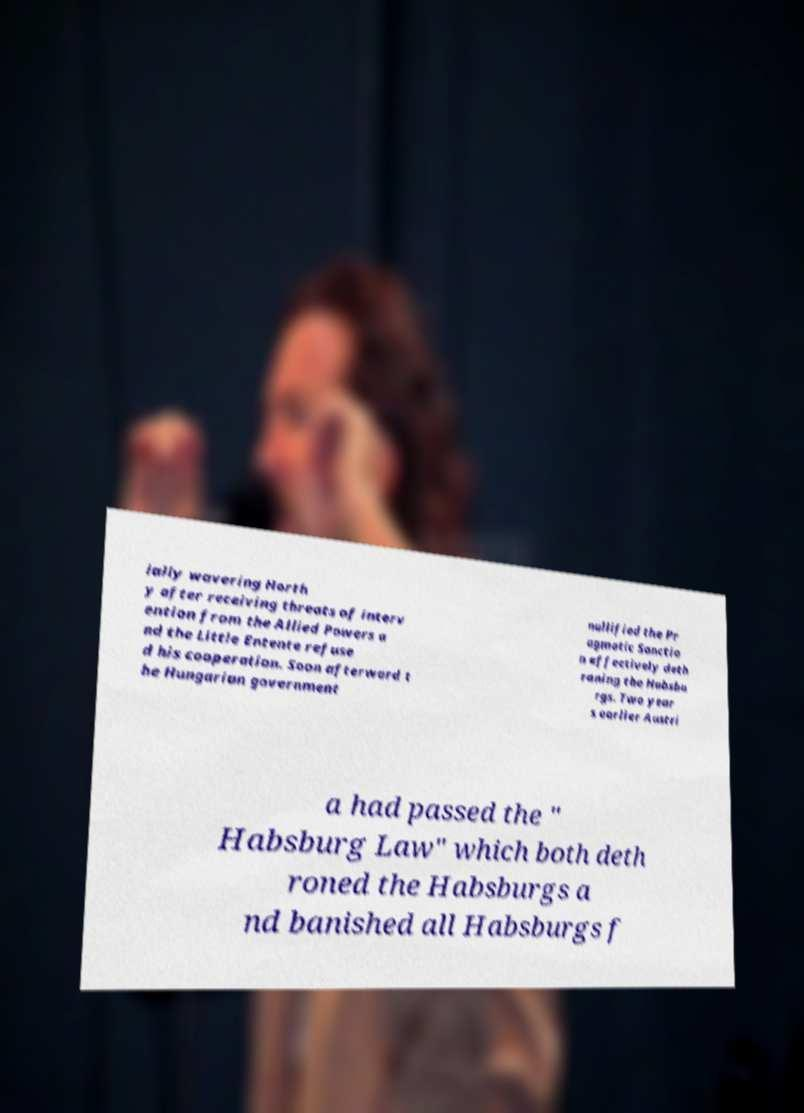For documentation purposes, I need the text within this image transcribed. Could you provide that? ially wavering Horth y after receiving threats of interv ention from the Allied Powers a nd the Little Entente refuse d his cooperation. Soon afterward t he Hungarian government nullified the Pr agmatic Sanctio n effectively deth roning the Habsbu rgs. Two year s earlier Austri a had passed the " Habsburg Law" which both deth roned the Habsburgs a nd banished all Habsburgs f 